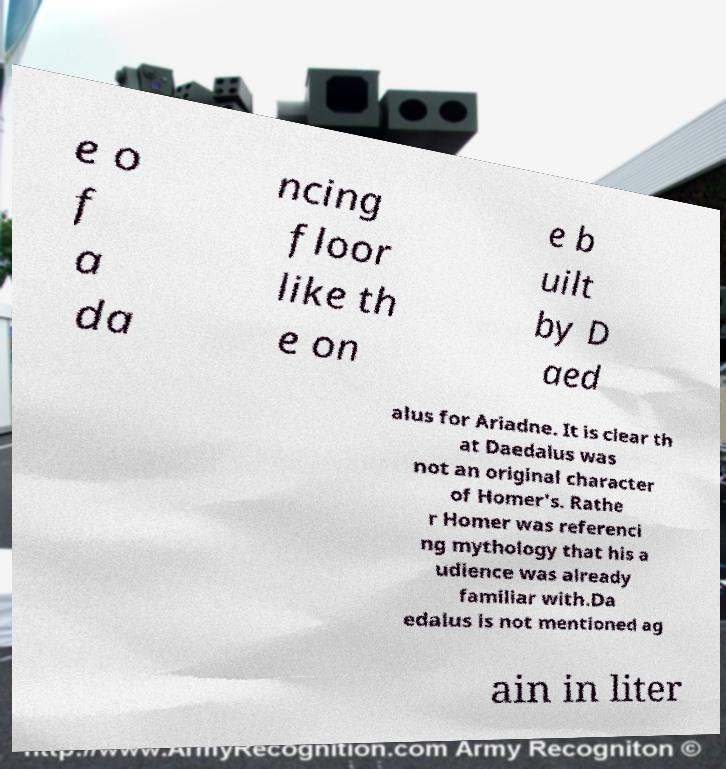There's text embedded in this image that I need extracted. Can you transcribe it verbatim? e o f a da ncing floor like th e on e b uilt by D aed alus for Ariadne. It is clear th at Daedalus was not an original character of Homer's. Rathe r Homer was referenci ng mythology that his a udience was already familiar with.Da edalus is not mentioned ag ain in liter 